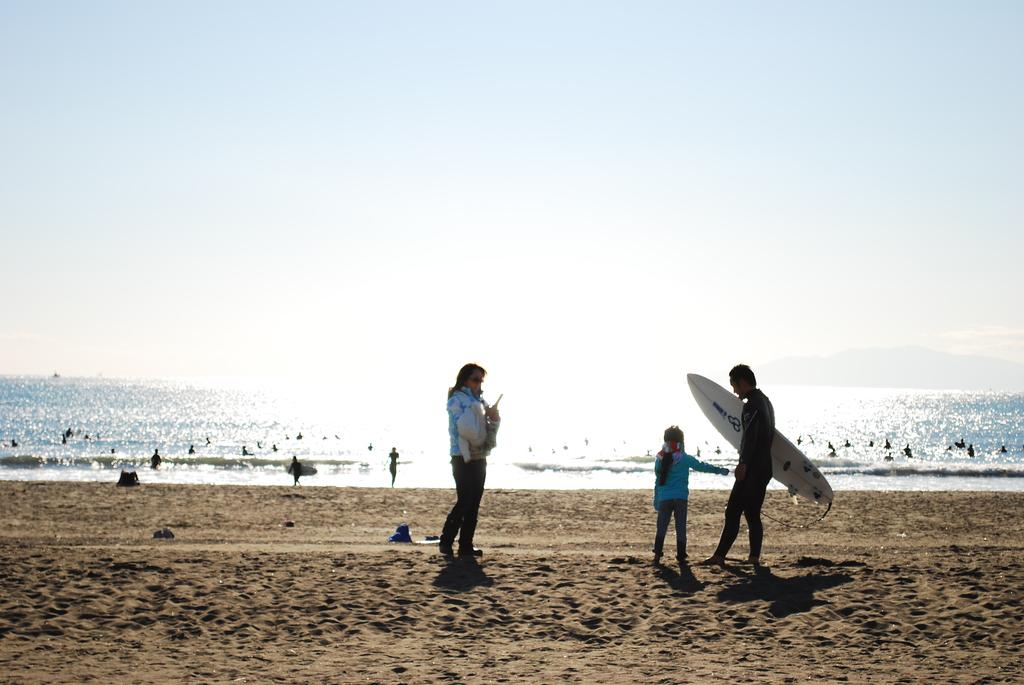What can be seen in the background of the image? There is a sky in the image. What is visible in the foreground of the image? There is water visible in the image. What is the surface on which the water is situated? There is ground in the image. Who or what is present in the image? There are people standing in the image. What hobbies do the people in the image engage in? There is no information about the hobbies of the people in the image, as the facts provided do not mention any specific activities or interests. 